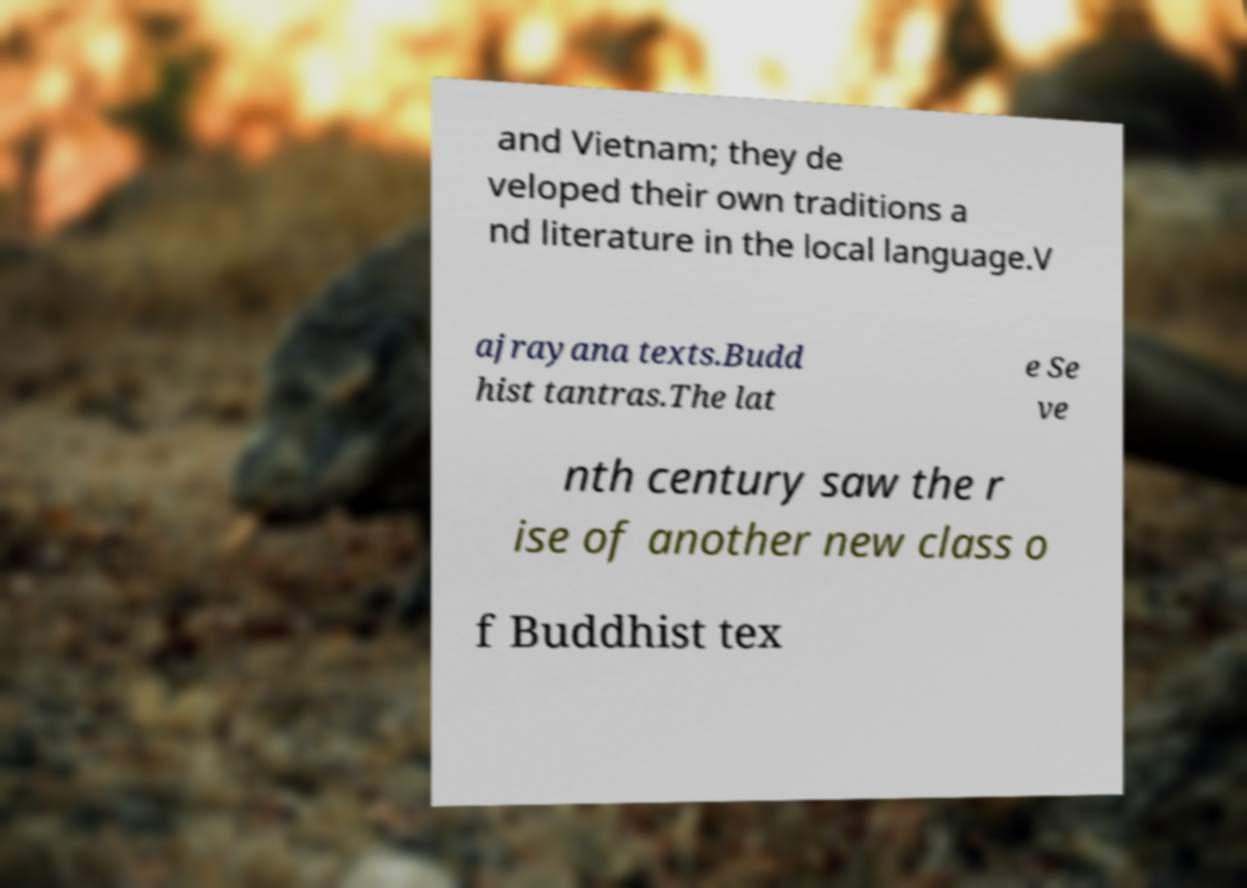Please read and relay the text visible in this image. What does it say? and Vietnam; they de veloped their own traditions a nd literature in the local language.V ajrayana texts.Budd hist tantras.The lat e Se ve nth century saw the r ise of another new class o f Buddhist tex 